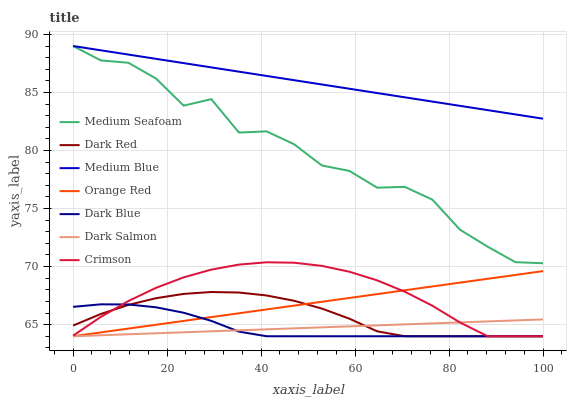Does Dark Salmon have the minimum area under the curve?
Answer yes or no. Yes. Does Medium Blue have the maximum area under the curve?
Answer yes or no. Yes. Does Medium Blue have the minimum area under the curve?
Answer yes or no. No. Does Dark Salmon have the maximum area under the curve?
Answer yes or no. No. Is Orange Red the smoothest?
Answer yes or no. Yes. Is Medium Seafoam the roughest?
Answer yes or no. Yes. Is Medium Blue the smoothest?
Answer yes or no. No. Is Medium Blue the roughest?
Answer yes or no. No. Does Dark Red have the lowest value?
Answer yes or no. Yes. Does Medium Blue have the lowest value?
Answer yes or no. No. Does Medium Seafoam have the highest value?
Answer yes or no. Yes. Does Dark Salmon have the highest value?
Answer yes or no. No. Is Dark Blue less than Medium Seafoam?
Answer yes or no. Yes. Is Medium Seafoam greater than Dark Salmon?
Answer yes or no. Yes. Does Dark Salmon intersect Orange Red?
Answer yes or no. Yes. Is Dark Salmon less than Orange Red?
Answer yes or no. No. Is Dark Salmon greater than Orange Red?
Answer yes or no. No. Does Dark Blue intersect Medium Seafoam?
Answer yes or no. No. 